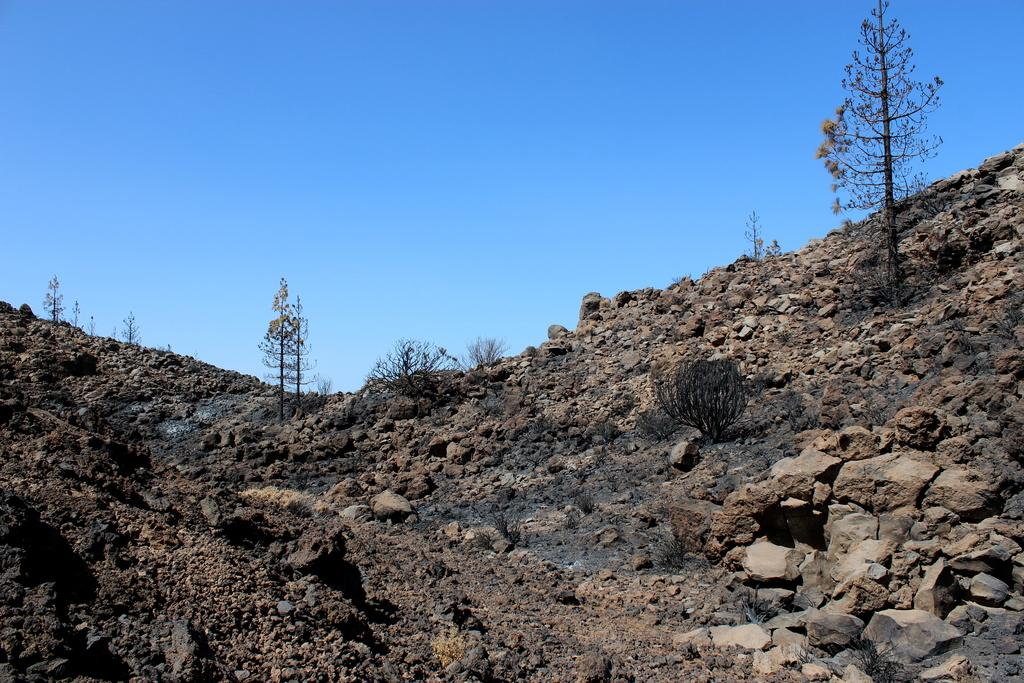What is the main geographical feature in the image? There is a mountain in the image. What can be found on the mountain? There are stones and dry trees on the mountain. What is the color of the soil on the mountain? The soil on the mountain appears to be black. What is visible at the top of the image? The sky is clear at the top of the image. What type of egg is being cooked on the mountain in the image? There is no egg or cooking activity present in the image; it features a mountain with stones, dry trees, and black soil. What is the desire of the mountain in the image? Mountains do not have desires, as they are inanimate objects. 